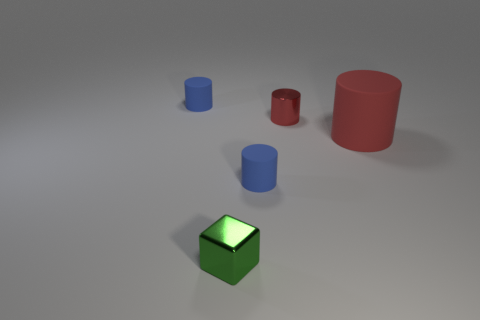Subtract all small metal cylinders. How many cylinders are left? 3 Add 2 blue cylinders. How many objects exist? 7 Subtract all red cylinders. How many cylinders are left? 2 Subtract 1 cylinders. How many cylinders are left? 3 Subtract all cylinders. How many objects are left? 1 Subtract all cyan blocks. How many blue cylinders are left? 2 Subtract 0 green spheres. How many objects are left? 5 Subtract all cyan cubes. Subtract all gray cylinders. How many cubes are left? 1 Subtract all small blue things. Subtract all large matte things. How many objects are left? 2 Add 5 big objects. How many big objects are left? 6 